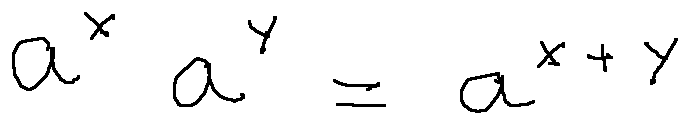<formula> <loc_0><loc_0><loc_500><loc_500>a ^ { x } a ^ { y } = a ^ { x + y }</formula> 